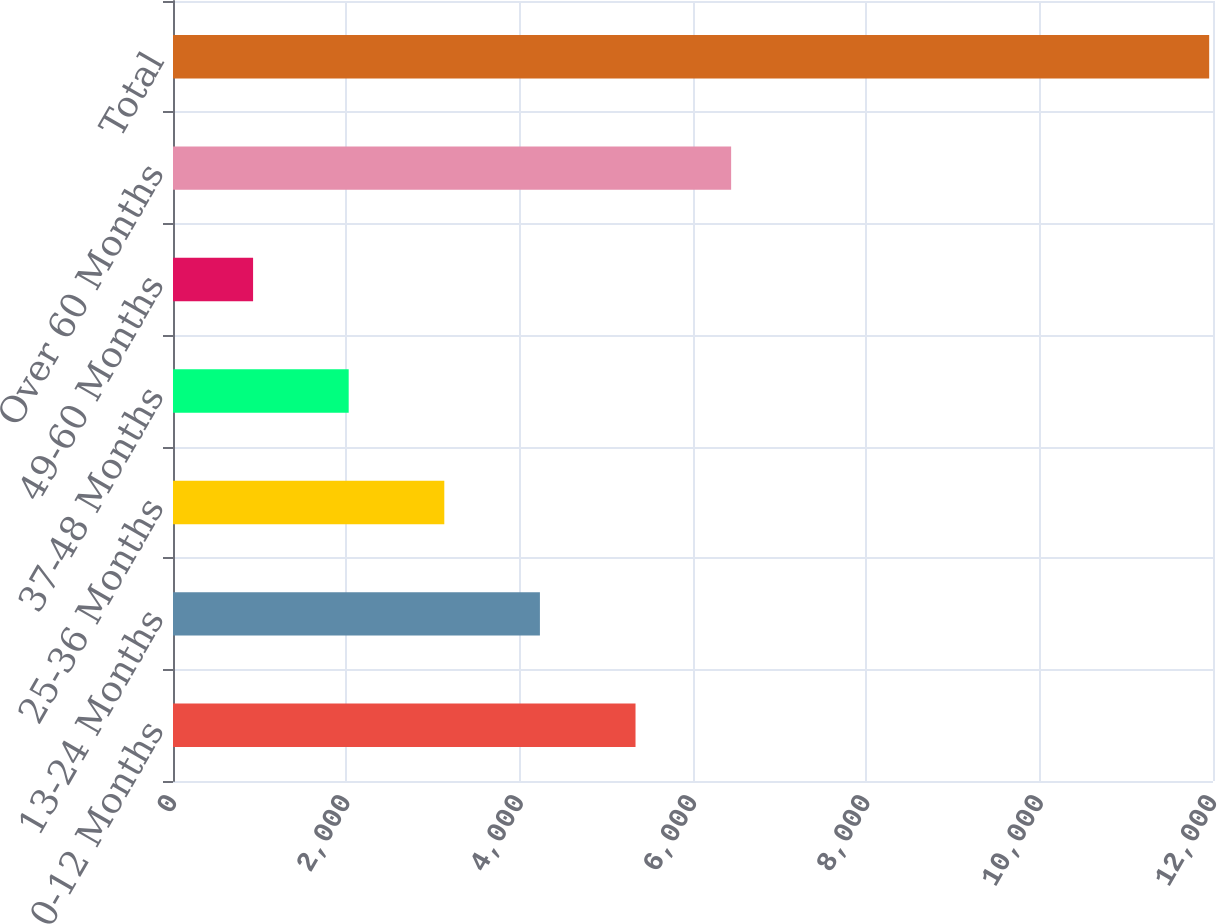Convert chart to OTSL. <chart><loc_0><loc_0><loc_500><loc_500><bar_chart><fcel>0-12 Months<fcel>13-24 Months<fcel>25-36 Months<fcel>37-48 Months<fcel>49-60 Months<fcel>Over 60 Months<fcel>Total<nl><fcel>5336.8<fcel>4233.6<fcel>3130.4<fcel>2027.2<fcel>924<fcel>6440<fcel>11956<nl></chart> 